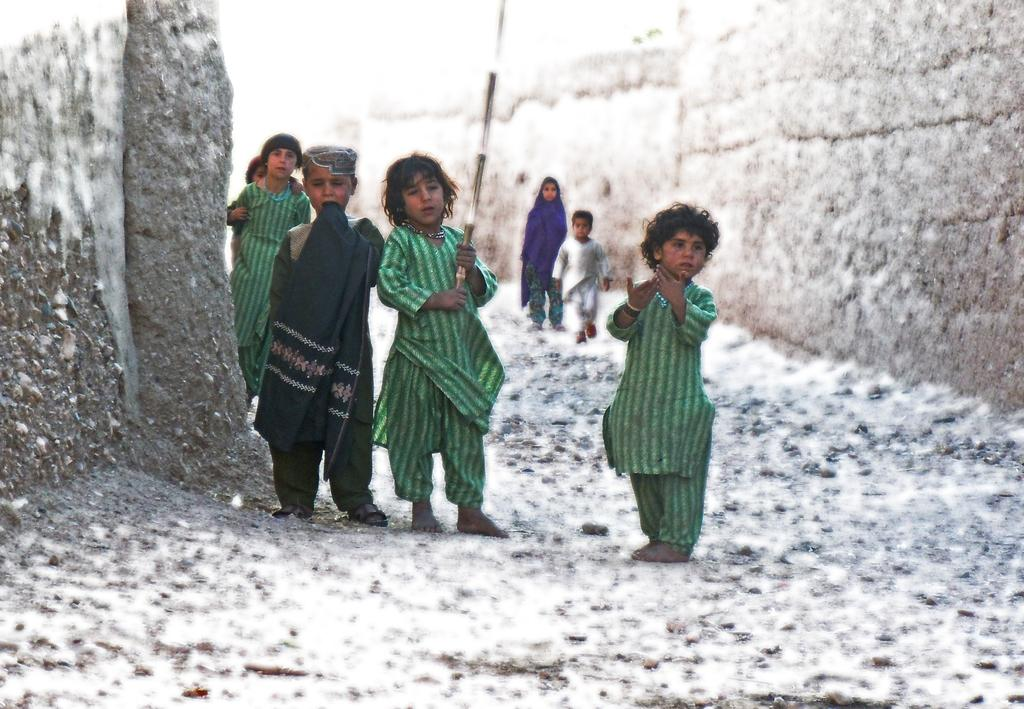Who is present in the image? There are children in the image. What are the children doing in the image? The children are standing and walking on a surface. Can you describe any objects the children are holding? One child is holding a stick in her hand. What can be seen on the sides of the image? There are walls on both the right and left sides of the image. How many brothers are present in the image? There is no mention of brothers in the image, so we cannot determine their presence. 